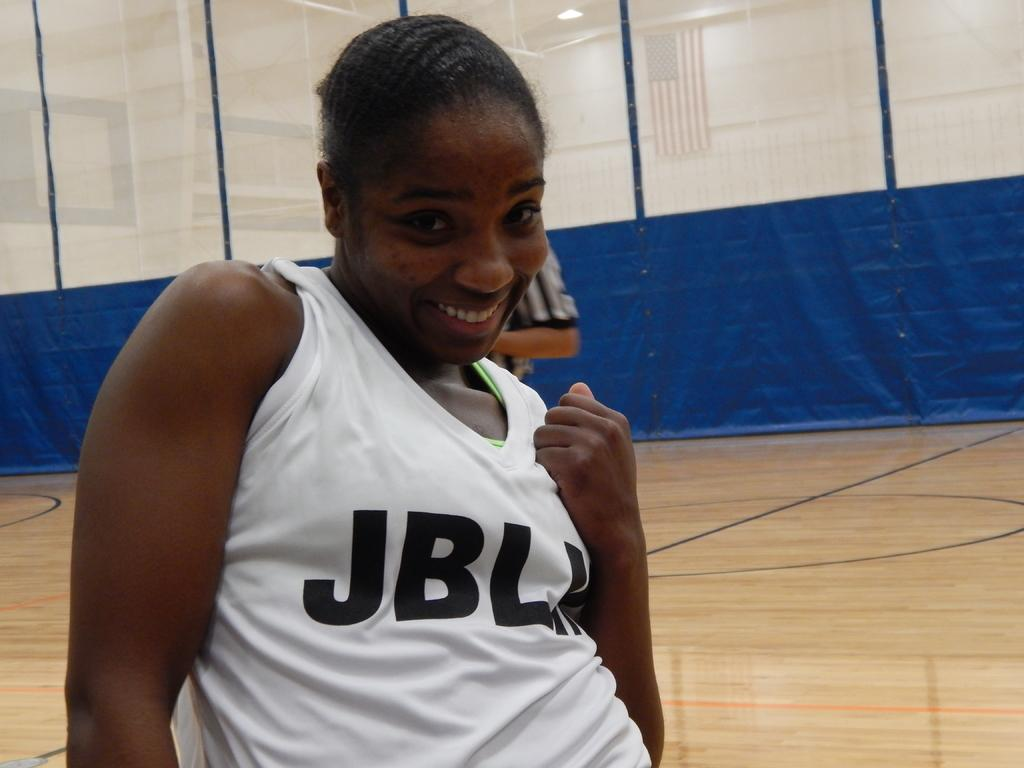<image>
Offer a succinct explanation of the picture presented. a girl in a white shirt that has the text jbl on her mid section. 